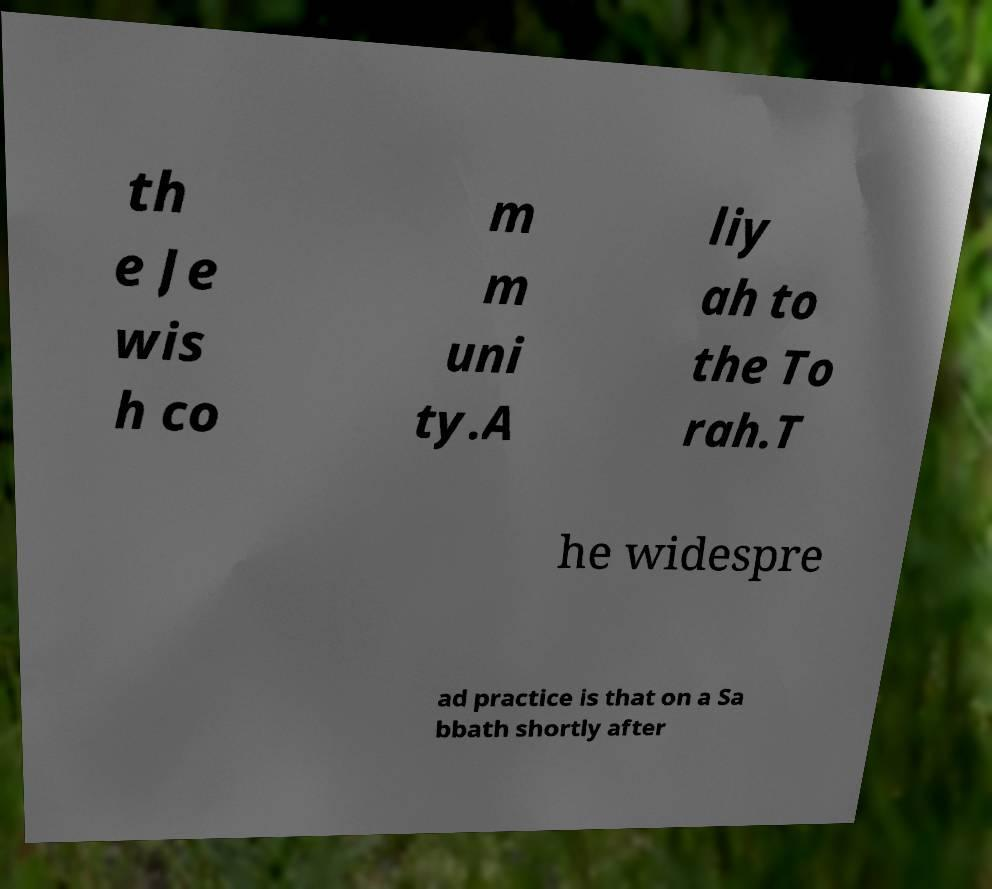Can you accurately transcribe the text from the provided image for me? th e Je wis h co m m uni ty.A liy ah to the To rah.T he widespre ad practice is that on a Sa bbath shortly after 